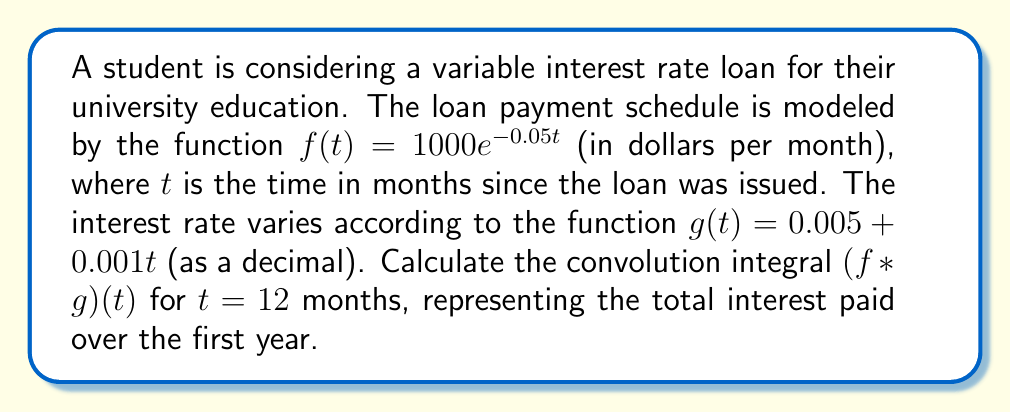Could you help me with this problem? To solve this problem, we need to use the convolution integral formula and follow these steps:

1) The convolution integral is defined as:

   $$(f * g)(t) = \int_0^t f(\tau)g(t-\tau)d\tau$$

2) Substituting our functions:

   $$(f * g)(t) = \int_0^t (1000e^{-0.05\tau})(0.005 + 0.001(t-\tau))d\tau$$

3) Expanding the integrand:

   $$(f * g)(t) = \int_0^t (5e^{-0.05\tau} + te^{-0.05\tau} - \tau e^{-0.05\tau})d\tau$$

4) Now, we need to evaluate this integral for $t = 12$:

   $$(f * g)(12) = \int_0^{12} (5e^{-0.05\tau} + 12e^{-0.05\tau} - \tau e^{-0.05\tau})d\tau$$

5) Let's break this into three integrals:

   $$I_1 = \int_0^{12} 5e^{-0.05\tau}d\tau$$
   $$I_2 = \int_0^{12} 12e^{-0.05\tau}d\tau$$
   $$I_3 = \int_0^{12} \tau e^{-0.05\tau}d\tau$$

6) Solving $I_1$ and $I_2$:

   $$I_1 = -100e^{-0.05\tau}|_0^{12} = -100(e^{-0.6} - 1) \approx 45.12$$
   $$I_2 = -240e^{-0.05\tau}|_0^{12} = -240(e^{-0.6} - 1) \approx 108.29$$

7) For $I_3$, we need integration by parts:

   $$I_3 = [-20\tau e^{-0.05\tau}|_0^{12} + \int_0^{12} 20e^{-0.05\tau}d\tau]$$
   $$= [-20 \cdot 12e^{-0.6} + 0] + [-400e^{-0.05\tau}|_0^{12}]$$
   $$= -240e^{-0.6} - 400(e^{-0.6} - 1) \approx -108.29 + 180.48 = 72.19$$

8) Sum the results:

   $$(f * g)(12) = I_1 + I_2 - I_3 = 45.12 + 108.29 - 72.19 = 81.22$$
Answer: The convolution integral $(f * g)(12)$ is approximately $81.22, representing the total interest paid (in dollars) over the first year of the loan. 